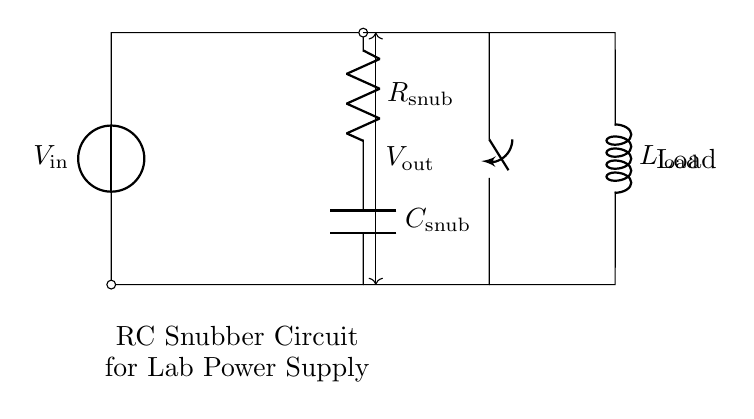What components are in the snubber circuit? The circuit contains a resistor, a capacitor, and a load inductor. These components are indicated in the diagram.
Answer: resistor, capacitor, inductor What is the purpose of the RC snubber circuit? The tension between the components is designed to suppress voltage spikes, protecting the circuit from damage. This is a common application for snubber circuits in power supplies.
Answer: suppress voltage spikes What does the symbol at the left represent? The symbol on the left represents a voltage source; it supplies the input voltage for the circuit.
Answer: voltage source How does the capacitor affect the snubber circuit? The capacitor temporarily stores and releases energy, which helps to absorb voltage spikes and smooth out fluctuations in the current.
Answer: absorbs voltage spikes Which component is used to control the connection in the circuit? The switch component controls the opening and closing of the circuit, affecting the flow of current to the load.
Answer: switch How is the voltage measured in the circuit? The output voltage is measured across the load, represented by the label showing the connection from the output of the snubber circuit to the load inductor.
Answer: across the load What is the role of the load inductor? The inductor serves as the load in the circuit; it reacts to changes in current and helps to smooth out the current flow through the circuit during operation.
Answer: load 